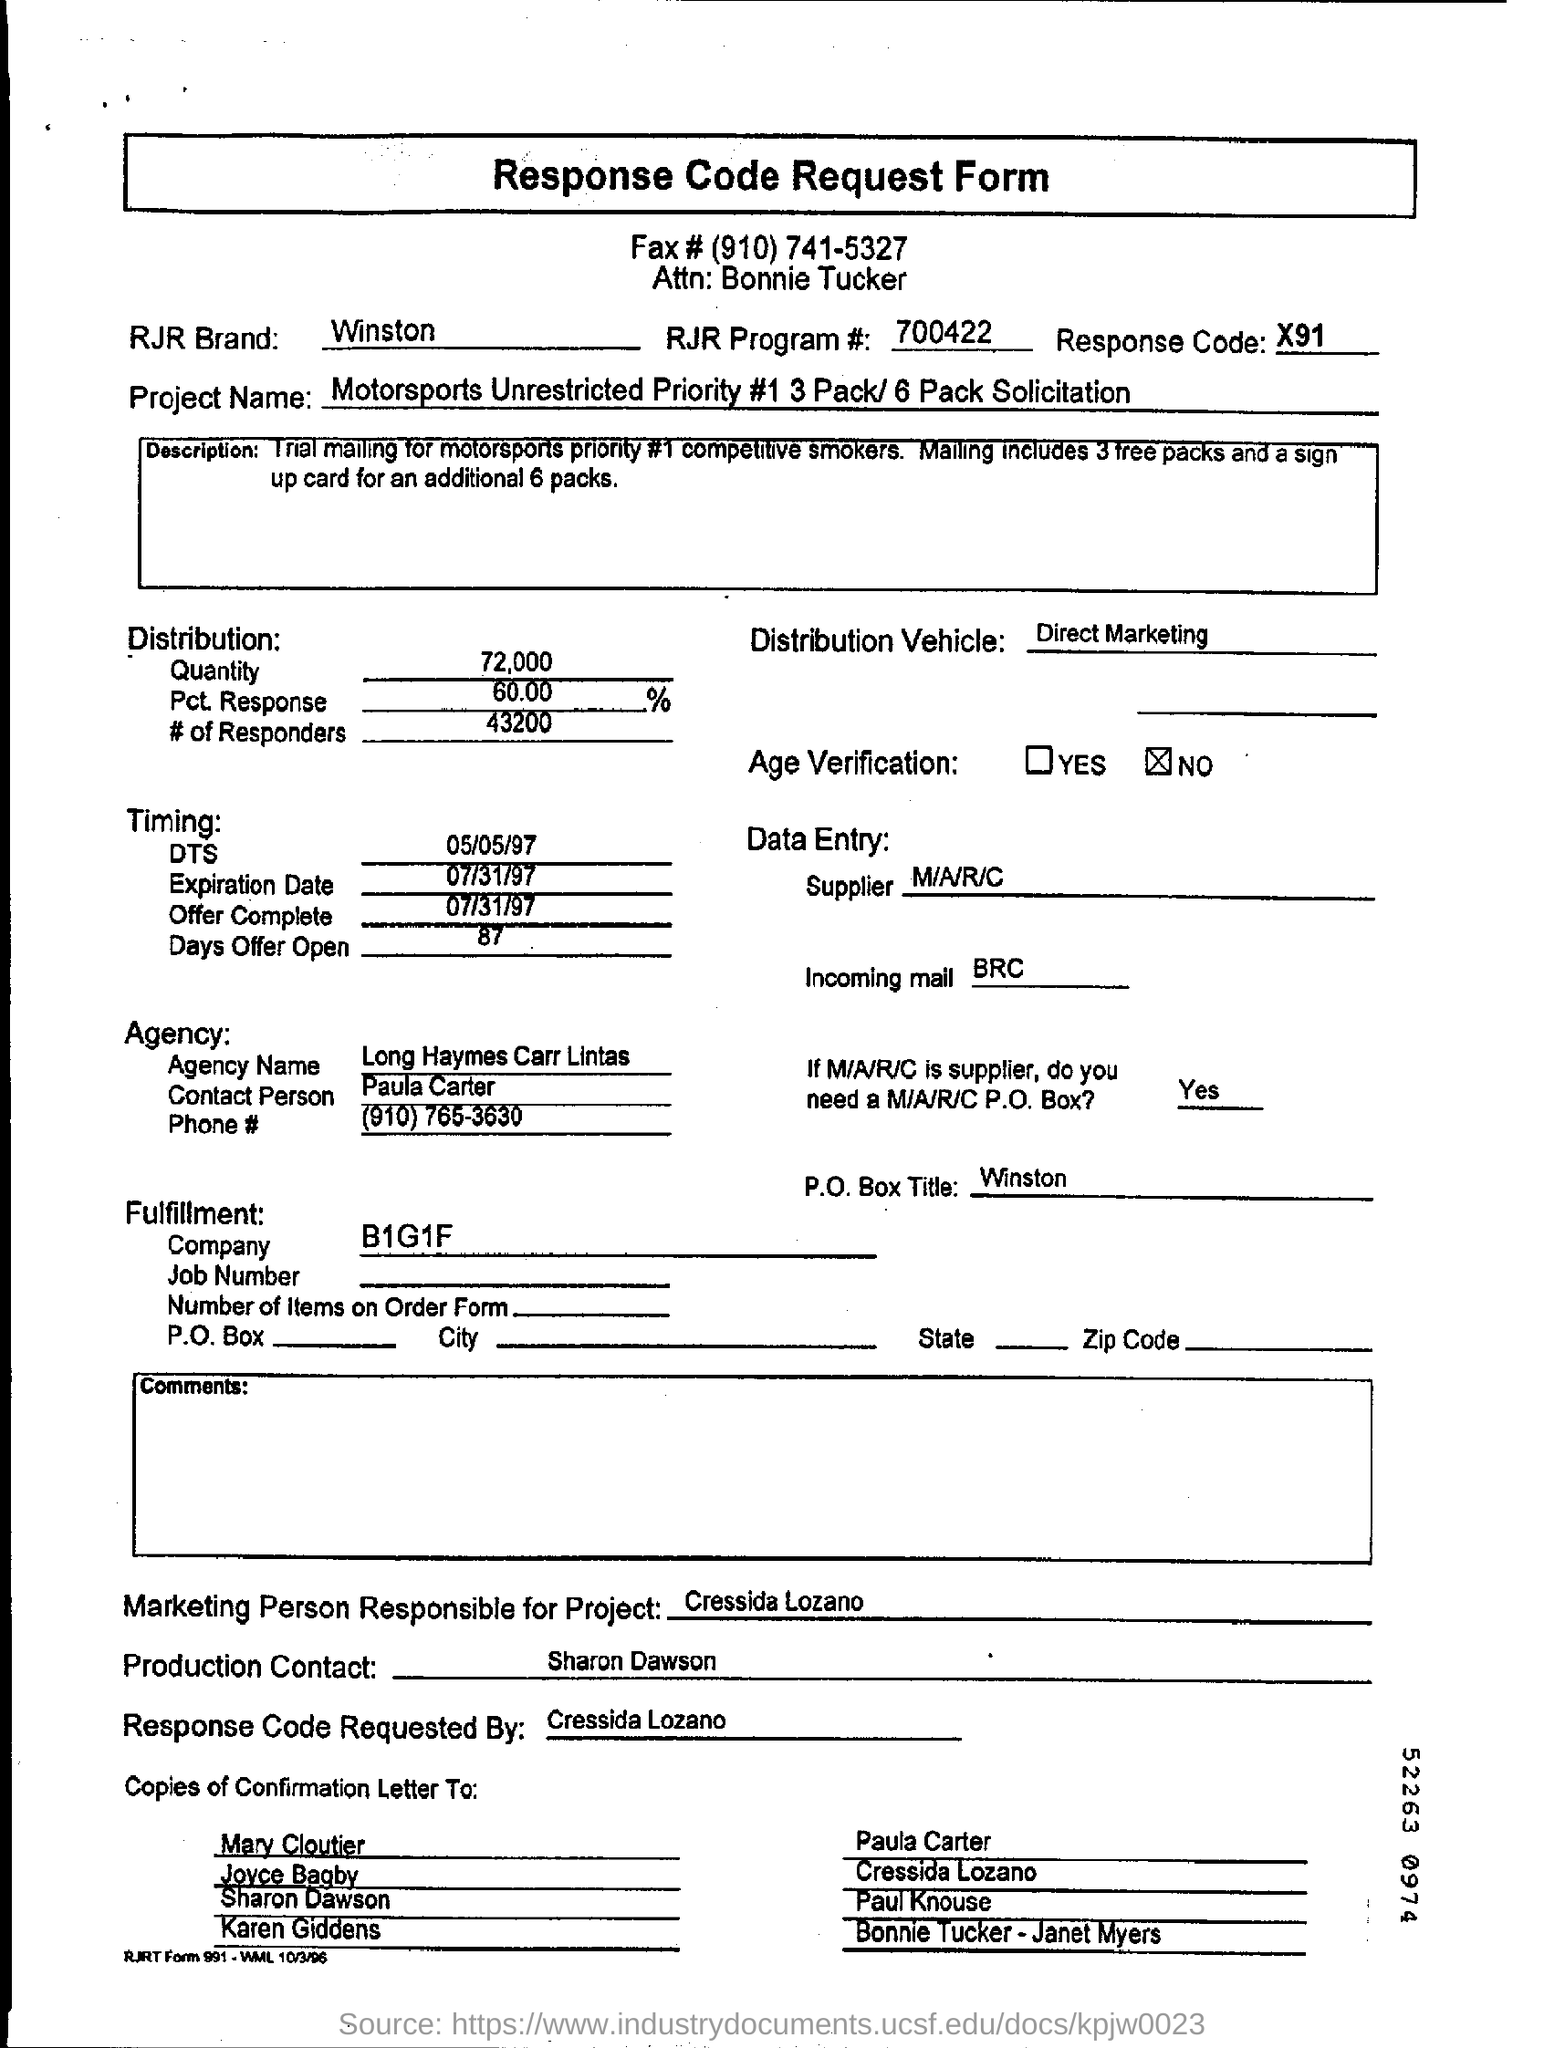What is the rjr brand mentioned ?
Your answer should be very brief. WINSTON. What is the rjr program no. mentioned ?
Keep it short and to the point. 700422. What is the response code mentioned ?
Offer a terse response. X91. What is the fax no. mentioned ?
Provide a succinct answer. (910) 741-5327. What is the p.o. box title mentioned ?
Provide a succinct answer. WINSTON. What is the value of quantity in distribution as mentioned in the given form ?
Ensure brevity in your answer.  72,000. What is the dts timing mentioned ?
Your response must be concise. 05/05/97. What is the expiration date mentioned ?
Your answer should be compact. 07/31/97. What is the offer complete date mentioned ?
Ensure brevity in your answer.  07/31/97. What is the agency name mentioned ?
Ensure brevity in your answer.  Long haymes carr lintas. 